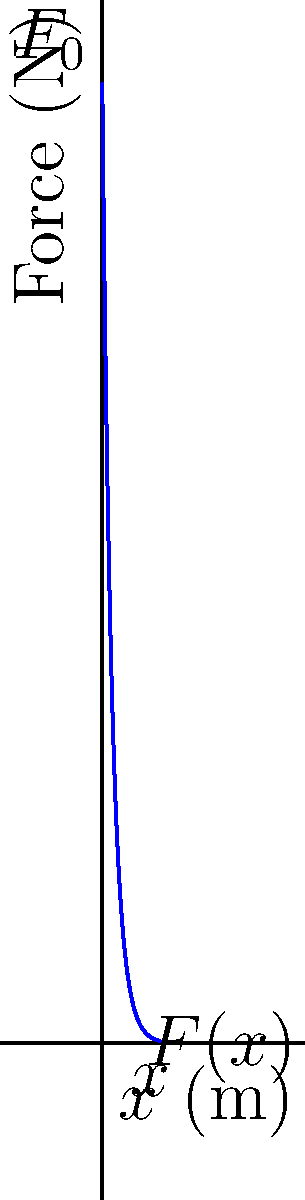In a wearable robotic assistance device for a fashion show, the applied force $F(x)$ decreases exponentially with distance $x$ according to the equation $F(x) = F_0e^{-x/d}$, where $F_0 = 50$ N and $d = 0.5$ m. Calculate the work done by this force when moving the device from $x = 0$ to $x = 2$ m. To calculate the work done by the force, we need to integrate the force function over the given distance:

1) The work is given by the integral: $W = \int_0^2 F(x) dx$

2) Substituting the given force function:
   $W = \int_0^2 50e^{-x/0.5} dx$

3) To integrate this, we can use the substitution method:
   Let $u = -x/0.5$, then $du = -1/0.5 dx$ or $dx = -0.5 du$

4) Changing the limits:
   When $x = 0$, $u = 0$
   When $x = 2$, $u = -4$

5) Rewriting the integral:
   $W = 50 \cdot (-0.5) \int_0^{-4} e^u du$

6) Integrating:
   $W = -25 [e^u]_0^{-4}$

7) Evaluating the limits:
   $W = -25 [e^{-4} - e^0]$
   $W = -25 [e^{-4} - 1]$

8) Calculating the final result:
   $W \approx 24.97$ J

Therefore, the work done by the force is approximately 24.97 J.
Answer: 24.97 J 